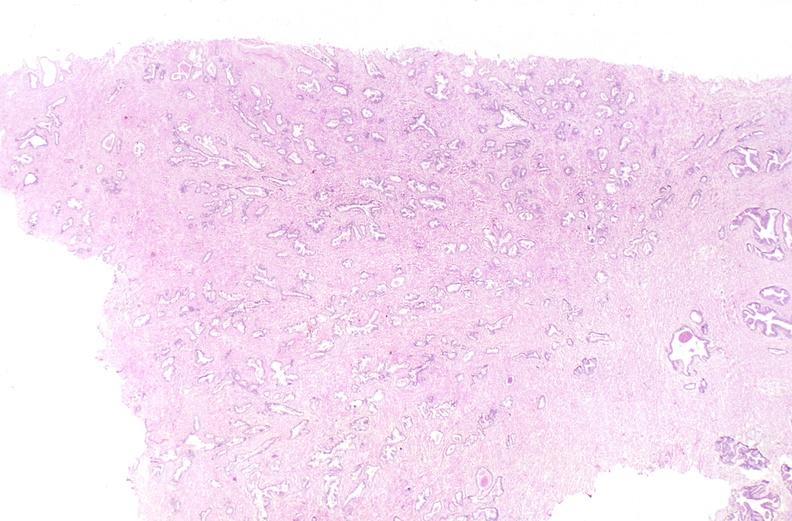does this image show prostate, normal histology?
Answer the question using a single word or phrase. Yes 